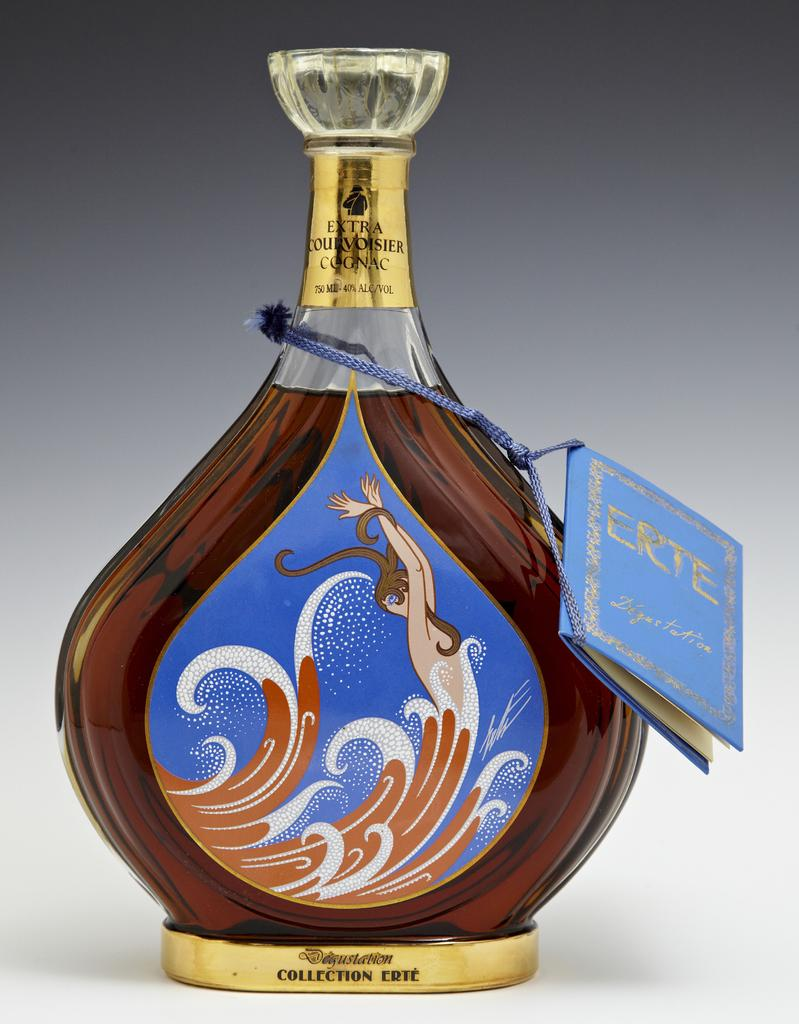What object can be seen in the image? There is a bottle in the image. Is there any additional information about the bottle? Yes, the bottle has a tag on it. What type of smoke can be seen coming out of the bottle in the image? There is no smoke coming out of the bottle in the image. How many letters are written on the tag attached to the bottle? The provided facts do not mention the number of letters on the tag, so we cannot answer this question definitively. 